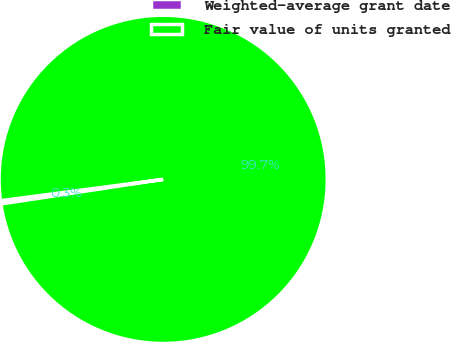Convert chart to OTSL. <chart><loc_0><loc_0><loc_500><loc_500><pie_chart><fcel>Weighted-average grant date<fcel>Fair value of units granted<nl><fcel>0.32%<fcel>99.68%<nl></chart> 